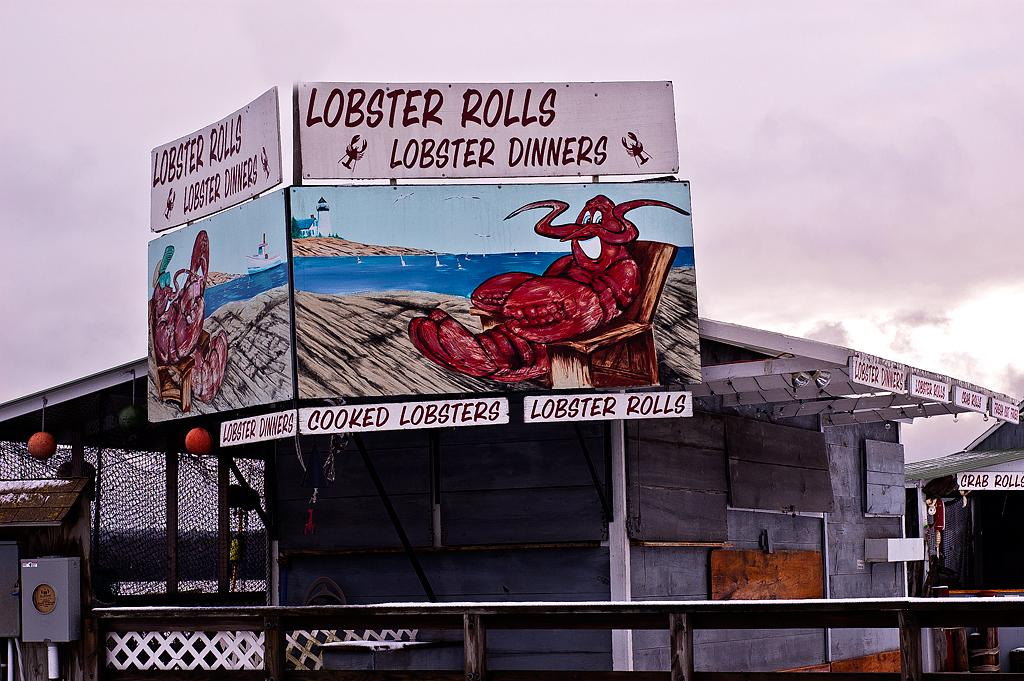<image>
Summarize the visual content of the image. A billboard for lobster rolls and cooked lobster dinners. 